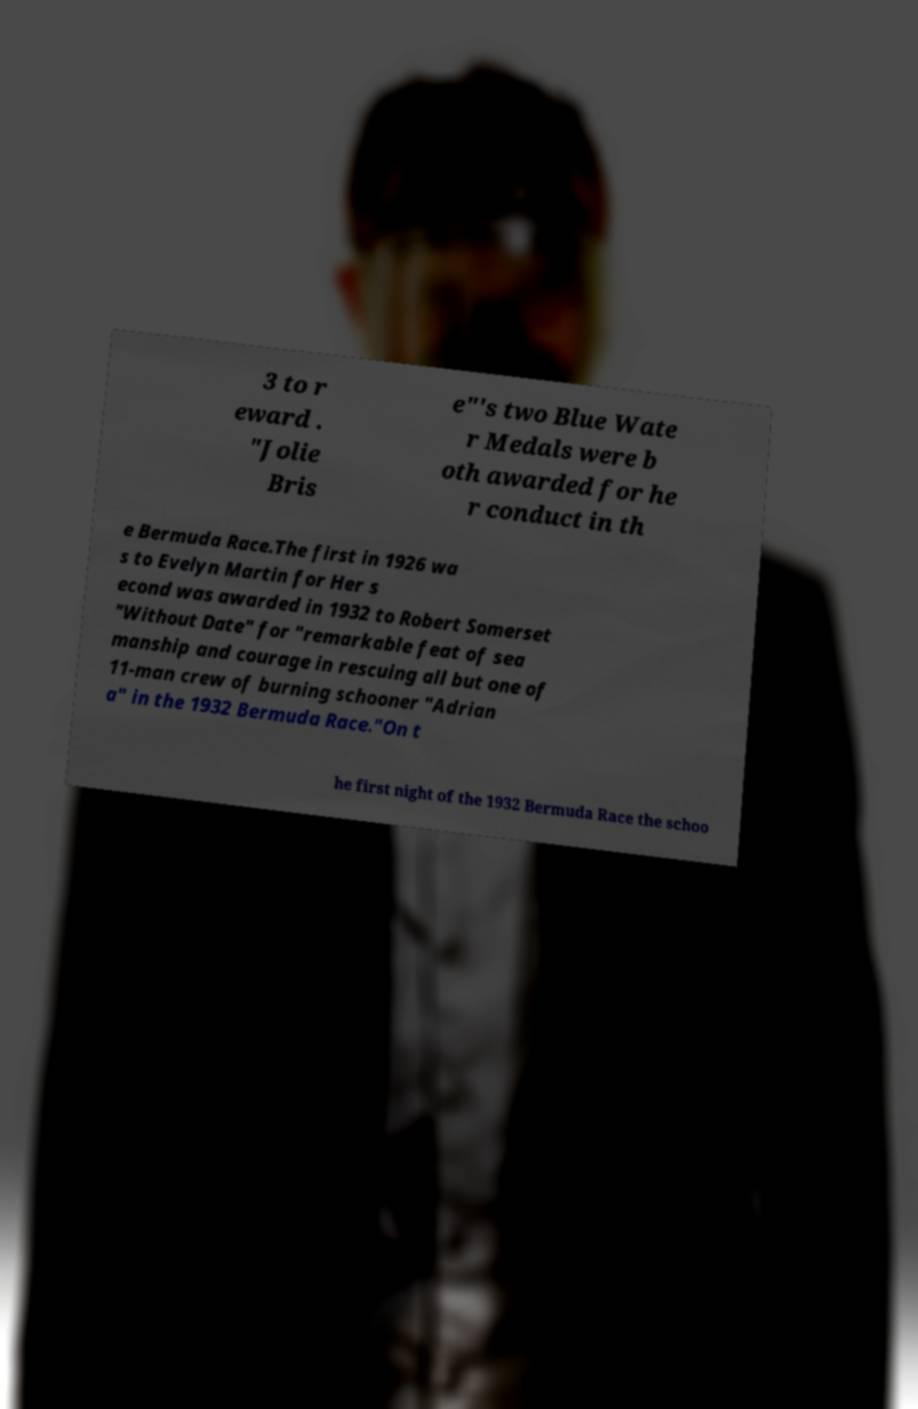What messages or text are displayed in this image? I need them in a readable, typed format. 3 to r eward . "Jolie Bris e"'s two Blue Wate r Medals were b oth awarded for he r conduct in th e Bermuda Race.The first in 1926 wa s to Evelyn Martin for Her s econd was awarded in 1932 to Robert Somerset "Without Date" for "remarkable feat of sea manship and courage in rescuing all but one of 11-man crew of burning schooner "Adrian a" in the 1932 Bermuda Race."On t he first night of the 1932 Bermuda Race the schoo 